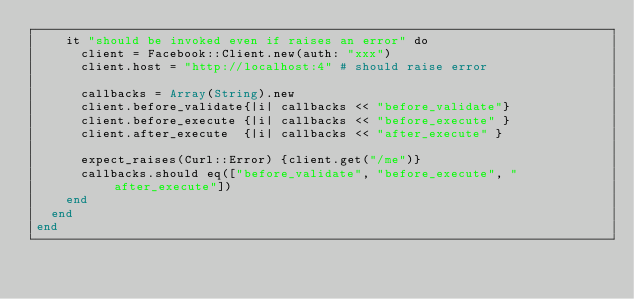Convert code to text. <code><loc_0><loc_0><loc_500><loc_500><_Crystal_>    it "should be invoked even if raises an error" do
      client = Facebook::Client.new(auth: "xxx")
      client.host = "http://localhost:4" # should raise error

      callbacks = Array(String).new
      client.before_validate{|i| callbacks << "before_validate"}
      client.before_execute {|i| callbacks << "before_execute" }
      client.after_execute  {|i| callbacks << "after_execute" }

      expect_raises(Curl::Error) {client.get("/me")}
      callbacks.should eq(["before_validate", "before_execute", "after_execute"])
    end
  end
end
</code> 